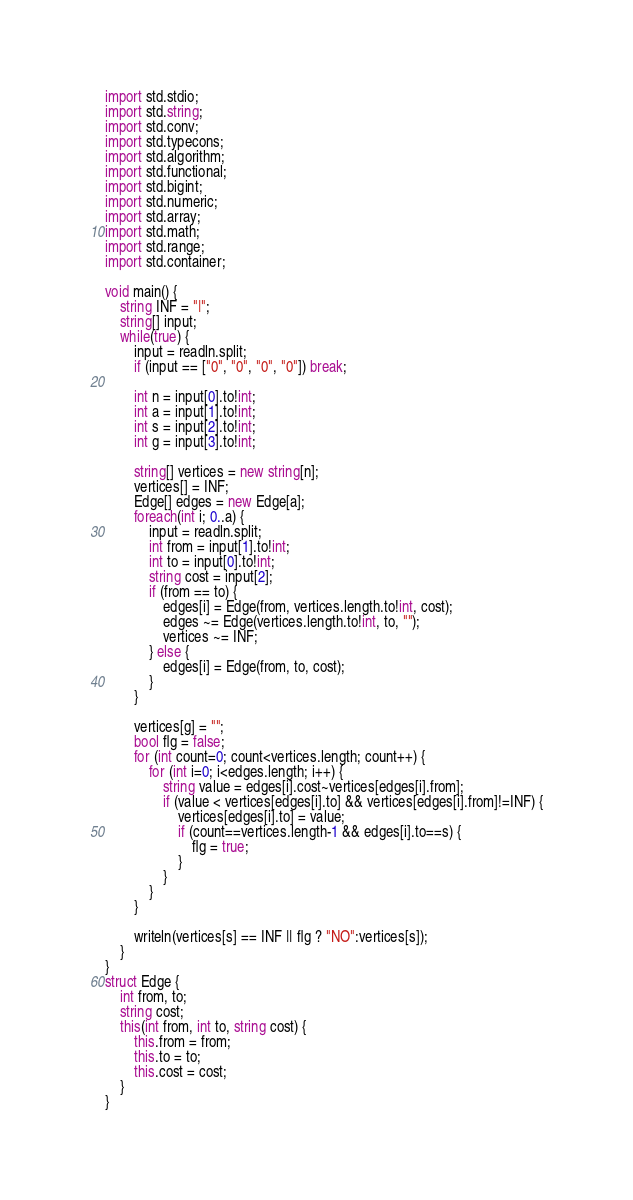Convert code to text. <code><loc_0><loc_0><loc_500><loc_500><_D_>import std.stdio;
import std.string;
import std.conv;
import std.typecons;
import std.algorithm;
import std.functional;
import std.bigint;
import std.numeric;
import std.array;
import std.math;
import std.range;
import std.container;

void main() {
    string INF = "|";
    string[] input;
    while(true) {
        input = readln.split;
        if (input == ["0", "0", "0", "0"]) break;

        int n = input[0].to!int;
        int a = input[1].to!int;
        int s = input[2].to!int;
        int g = input[3].to!int;

        string[] vertices = new string[n];
        vertices[] = INF;
        Edge[] edges = new Edge[a];
        foreach(int i; 0..a) {
            input = readln.split;
            int from = input[1].to!int;
            int to = input[0].to!int;
            string cost = input[2];
            if (from == to) {
                edges[i] = Edge(from, vertices.length.to!int, cost);
                edges ~= Edge(vertices.length.to!int, to, "");
                vertices ~= INF;
            } else {
                edges[i] = Edge(from, to, cost);
            }
        }

        vertices[g] = "";
        bool flg = false;
        for (int count=0; count<vertices.length; count++) {
            for (int i=0; i<edges.length; i++) {
                string value = edges[i].cost~vertices[edges[i].from];
                if (value < vertices[edges[i].to] && vertices[edges[i].from]!=INF) {
                    vertices[edges[i].to] = value;
                    if (count==vertices.length-1 && edges[i].to==s) {
                        flg = true;
                    }
                }
            }
        }

        writeln(vertices[s] == INF || flg ? "NO":vertices[s]);
    }
}
struct Edge {
    int from, to;
    string cost;
    this(int from, int to, string cost) {
        this.from = from;
        this.to = to;
        this.cost = cost;
    }
}</code> 